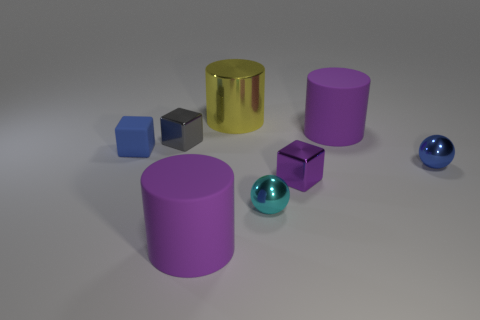What number of yellow objects have the same material as the tiny purple block?
Make the answer very short. 1. The other cube that is the same material as the purple block is what color?
Make the answer very short. Gray. What is the shape of the cyan object?
Keep it short and to the point. Sphere. What number of shiny spheres have the same color as the matte cube?
Provide a short and direct response. 1. What shape is the gray metal thing that is the same size as the blue matte cube?
Your answer should be very brief. Cube. Are there any blue rubber things that have the same size as the cyan ball?
Keep it short and to the point. Yes. What material is the blue ball that is the same size as the gray metallic thing?
Offer a very short reply. Metal. There is a blue thing right of the big purple object in front of the cyan shiny object; what size is it?
Offer a terse response. Small. There is a matte thing that is to the left of the gray block; is its size the same as the big yellow shiny object?
Provide a succinct answer. No. Is the number of cyan metallic balls that are on the right side of the small purple thing greater than the number of large yellow cylinders in front of the yellow thing?
Ensure brevity in your answer.  No. 